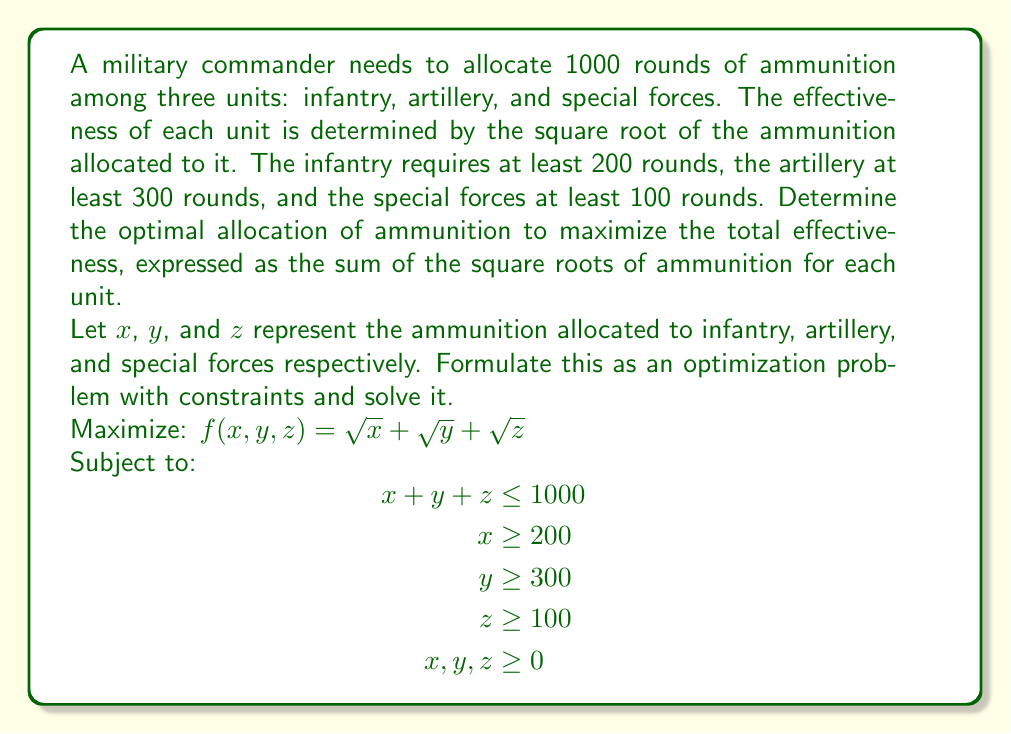Solve this math problem. To solve this optimization problem, we'll use the method of Lagrange multipliers:

1) Form the Lagrangian function:
   $$L(x,y,z,\lambda) = \sqrt{x} + \sqrt{y} + \sqrt{z} + \lambda(1000 - x - y - z)$$

2) Take partial derivatives and set them equal to zero:
   $$\begin{aligned}
   \frac{\partial L}{\partial x} &= \frac{1}{2\sqrt{x}} - \lambda = 0 \\
   \frac{\partial L}{\partial y} &= \frac{1}{2\sqrt{y}} - \lambda = 0 \\
   \frac{\partial L}{\partial z} &= \frac{1}{2\sqrt{z}} - \lambda = 0 \\
   \frac{\partial L}{\partial \lambda} &= 1000 - x - y - z = 0
   \end{aligned}$$

3) From the first three equations, we can deduce that $x = y = z$ at the optimum point.

4) Substituting this into the last equation:
   $$1000 - 3x = 0$$
   $$x = y = z = \frac{1000}{3} \approx 333.33$$

5) Check the constraints:
   - $x = 333.33 > 200$ (satisfied)
   - $y = 333.33 > 300$ (satisfied)
   - $z = 333.33 > 100$ (satisfied)

Therefore, the optimal allocation is to distribute the ammunition equally among the three units.
Answer: The optimal allocation is:
Infantry: 333 rounds
Artillery: 333 rounds
Special Forces: 334 rounds

Total effectiveness: $\sqrt{333} + \sqrt{333} + \sqrt{334} \approx 54.85$ 